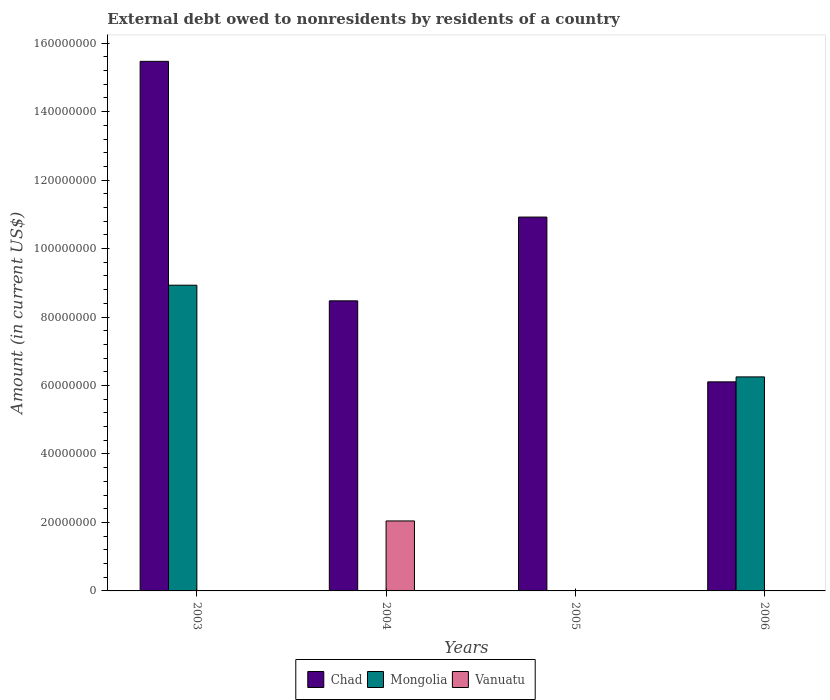Are the number of bars per tick equal to the number of legend labels?
Your answer should be compact. No. Are the number of bars on each tick of the X-axis equal?
Provide a short and direct response. No. How many bars are there on the 1st tick from the left?
Ensure brevity in your answer.  2. How many bars are there on the 1st tick from the right?
Offer a very short reply. 2. What is the external debt owed by residents in Vanuatu in 2004?
Your answer should be very brief. 2.04e+07. Across all years, what is the maximum external debt owed by residents in Vanuatu?
Your response must be concise. 2.04e+07. Across all years, what is the minimum external debt owed by residents in Vanuatu?
Offer a very short reply. 0. In which year was the external debt owed by residents in Vanuatu maximum?
Provide a succinct answer. 2004. What is the total external debt owed by residents in Mongolia in the graph?
Give a very brief answer. 1.52e+08. What is the difference between the external debt owed by residents in Chad in 2003 and that in 2006?
Ensure brevity in your answer.  9.36e+07. What is the average external debt owed by residents in Mongolia per year?
Your answer should be very brief. 3.80e+07. In the year 2006, what is the difference between the external debt owed by residents in Mongolia and external debt owed by residents in Chad?
Your answer should be compact. 1.45e+06. What is the ratio of the external debt owed by residents in Chad in 2003 to that in 2006?
Keep it short and to the point. 2.53. Is the external debt owed by residents in Mongolia in 2003 less than that in 2006?
Your answer should be very brief. No. Is the difference between the external debt owed by residents in Mongolia in 2003 and 2006 greater than the difference between the external debt owed by residents in Chad in 2003 and 2006?
Offer a very short reply. No. What is the difference between the highest and the second highest external debt owed by residents in Chad?
Keep it short and to the point. 4.55e+07. What is the difference between the highest and the lowest external debt owed by residents in Vanuatu?
Make the answer very short. 2.04e+07. In how many years, is the external debt owed by residents in Vanuatu greater than the average external debt owed by residents in Vanuatu taken over all years?
Ensure brevity in your answer.  1. Is it the case that in every year, the sum of the external debt owed by residents in Chad and external debt owed by residents in Vanuatu is greater than the external debt owed by residents in Mongolia?
Make the answer very short. No. How many years are there in the graph?
Keep it short and to the point. 4. What is the difference between two consecutive major ticks on the Y-axis?
Ensure brevity in your answer.  2.00e+07. Does the graph contain any zero values?
Ensure brevity in your answer.  Yes. Does the graph contain grids?
Provide a succinct answer. No. How are the legend labels stacked?
Your answer should be compact. Horizontal. What is the title of the graph?
Make the answer very short. External debt owed to nonresidents by residents of a country. What is the Amount (in current US$) of Chad in 2003?
Offer a terse response. 1.55e+08. What is the Amount (in current US$) of Mongolia in 2003?
Keep it short and to the point. 8.93e+07. What is the Amount (in current US$) of Vanuatu in 2003?
Make the answer very short. 0. What is the Amount (in current US$) of Chad in 2004?
Your response must be concise. 8.47e+07. What is the Amount (in current US$) in Mongolia in 2004?
Offer a very short reply. 0. What is the Amount (in current US$) in Vanuatu in 2004?
Provide a short and direct response. 2.04e+07. What is the Amount (in current US$) of Chad in 2005?
Offer a terse response. 1.09e+08. What is the Amount (in current US$) of Mongolia in 2005?
Provide a succinct answer. 0. What is the Amount (in current US$) of Chad in 2006?
Provide a succinct answer. 6.11e+07. What is the Amount (in current US$) in Mongolia in 2006?
Your answer should be compact. 6.25e+07. What is the Amount (in current US$) of Vanuatu in 2006?
Provide a short and direct response. 0. Across all years, what is the maximum Amount (in current US$) in Chad?
Offer a terse response. 1.55e+08. Across all years, what is the maximum Amount (in current US$) in Mongolia?
Make the answer very short. 8.93e+07. Across all years, what is the maximum Amount (in current US$) in Vanuatu?
Give a very brief answer. 2.04e+07. Across all years, what is the minimum Amount (in current US$) in Chad?
Give a very brief answer. 6.11e+07. Across all years, what is the minimum Amount (in current US$) in Vanuatu?
Your answer should be very brief. 0. What is the total Amount (in current US$) of Chad in the graph?
Make the answer very short. 4.10e+08. What is the total Amount (in current US$) of Mongolia in the graph?
Keep it short and to the point. 1.52e+08. What is the total Amount (in current US$) of Vanuatu in the graph?
Give a very brief answer. 2.04e+07. What is the difference between the Amount (in current US$) of Chad in 2003 and that in 2004?
Provide a succinct answer. 7.00e+07. What is the difference between the Amount (in current US$) in Chad in 2003 and that in 2005?
Ensure brevity in your answer.  4.55e+07. What is the difference between the Amount (in current US$) of Chad in 2003 and that in 2006?
Offer a terse response. 9.36e+07. What is the difference between the Amount (in current US$) of Mongolia in 2003 and that in 2006?
Offer a very short reply. 2.68e+07. What is the difference between the Amount (in current US$) of Chad in 2004 and that in 2005?
Your answer should be compact. -2.45e+07. What is the difference between the Amount (in current US$) of Chad in 2004 and that in 2006?
Give a very brief answer. 2.37e+07. What is the difference between the Amount (in current US$) of Chad in 2005 and that in 2006?
Provide a short and direct response. 4.81e+07. What is the difference between the Amount (in current US$) of Chad in 2003 and the Amount (in current US$) of Vanuatu in 2004?
Offer a terse response. 1.34e+08. What is the difference between the Amount (in current US$) of Mongolia in 2003 and the Amount (in current US$) of Vanuatu in 2004?
Ensure brevity in your answer.  6.89e+07. What is the difference between the Amount (in current US$) in Chad in 2003 and the Amount (in current US$) in Mongolia in 2006?
Provide a succinct answer. 9.22e+07. What is the difference between the Amount (in current US$) in Chad in 2004 and the Amount (in current US$) in Mongolia in 2006?
Give a very brief answer. 2.22e+07. What is the difference between the Amount (in current US$) in Chad in 2005 and the Amount (in current US$) in Mongolia in 2006?
Keep it short and to the point. 4.67e+07. What is the average Amount (in current US$) in Chad per year?
Provide a short and direct response. 1.02e+08. What is the average Amount (in current US$) in Mongolia per year?
Ensure brevity in your answer.  3.80e+07. What is the average Amount (in current US$) in Vanuatu per year?
Provide a short and direct response. 5.11e+06. In the year 2003, what is the difference between the Amount (in current US$) in Chad and Amount (in current US$) in Mongolia?
Provide a succinct answer. 6.54e+07. In the year 2004, what is the difference between the Amount (in current US$) of Chad and Amount (in current US$) of Vanuatu?
Offer a very short reply. 6.43e+07. In the year 2006, what is the difference between the Amount (in current US$) in Chad and Amount (in current US$) in Mongolia?
Provide a succinct answer. -1.45e+06. What is the ratio of the Amount (in current US$) in Chad in 2003 to that in 2004?
Make the answer very short. 1.83. What is the ratio of the Amount (in current US$) of Chad in 2003 to that in 2005?
Your answer should be compact. 1.42. What is the ratio of the Amount (in current US$) of Chad in 2003 to that in 2006?
Make the answer very short. 2.53. What is the ratio of the Amount (in current US$) of Mongolia in 2003 to that in 2006?
Provide a short and direct response. 1.43. What is the ratio of the Amount (in current US$) in Chad in 2004 to that in 2005?
Your answer should be compact. 0.78. What is the ratio of the Amount (in current US$) of Chad in 2004 to that in 2006?
Offer a very short reply. 1.39. What is the ratio of the Amount (in current US$) of Chad in 2005 to that in 2006?
Your answer should be compact. 1.79. What is the difference between the highest and the second highest Amount (in current US$) in Chad?
Offer a very short reply. 4.55e+07. What is the difference between the highest and the lowest Amount (in current US$) in Chad?
Your answer should be very brief. 9.36e+07. What is the difference between the highest and the lowest Amount (in current US$) of Mongolia?
Provide a short and direct response. 8.93e+07. What is the difference between the highest and the lowest Amount (in current US$) in Vanuatu?
Offer a terse response. 2.04e+07. 